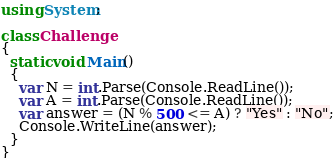Convert code to text. <code><loc_0><loc_0><loc_500><loc_500><_C#_>using System;

class Challenge
{
  static void Main()
  {
    var N = int.Parse(Console.ReadLine());
    var A = int.Parse(Console.ReadLine());
    var answer = (N % 500 <= A) ? "Yes" : "No";
    Console.WriteLine(answer);
  }
}
</code> 